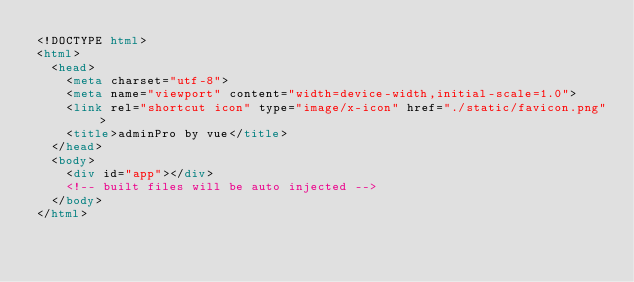Convert code to text. <code><loc_0><loc_0><loc_500><loc_500><_HTML_><!DOCTYPE html>
<html>
  <head>
    <meta charset="utf-8">
    <meta name="viewport" content="width=device-width,initial-scale=1.0">
    <link rel="shortcut icon" type="image/x-icon" href="./static/favicon.png">
    <title>adminPro by vue</title>
  </head>
  <body>
    <div id="app"></div>
    <!-- built files will be auto injected -->
  </body>
</html>
</code> 